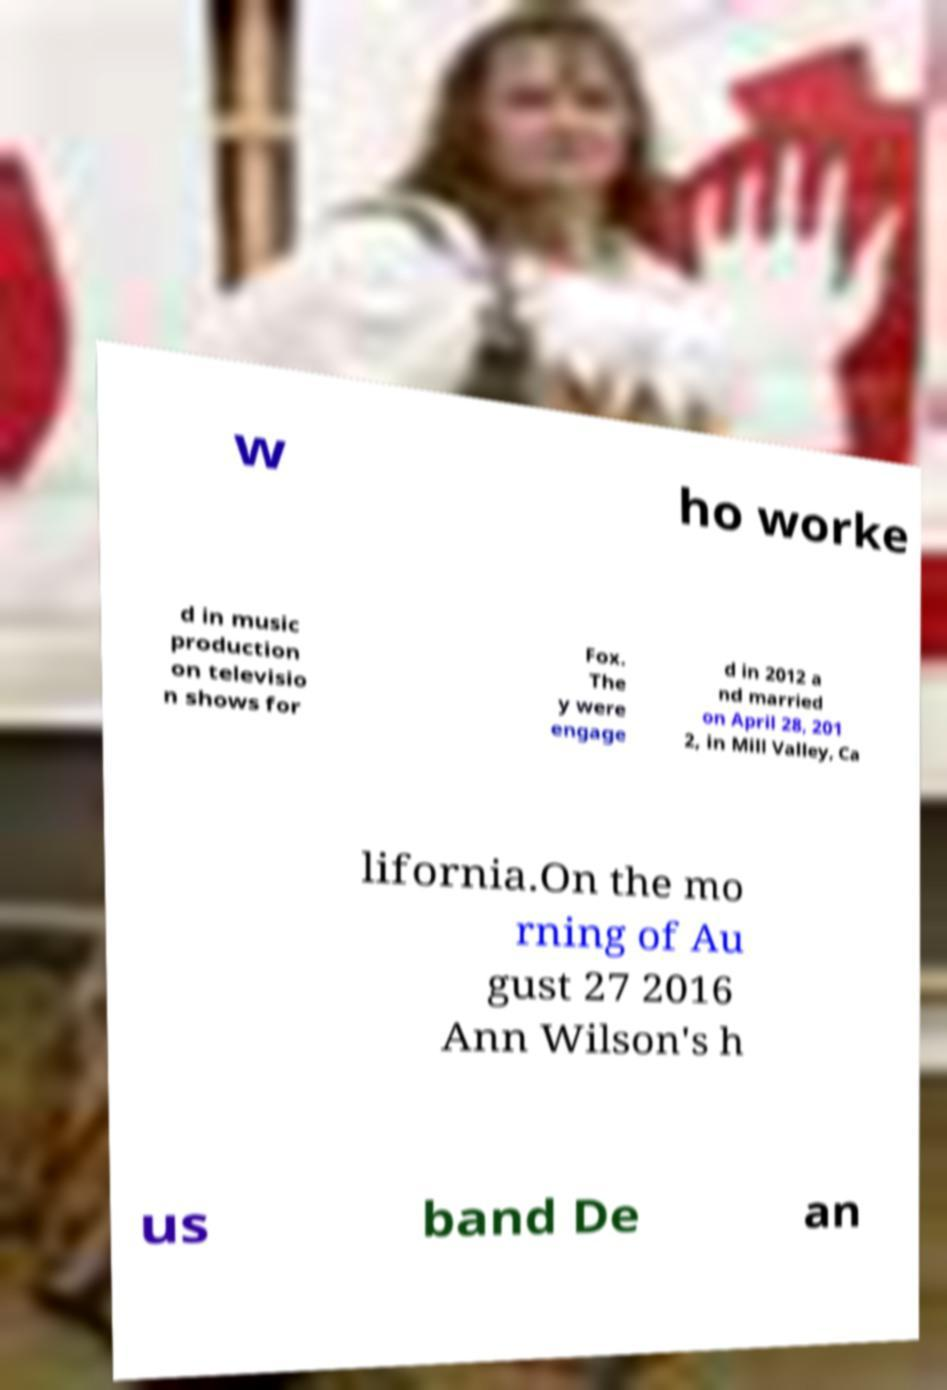For documentation purposes, I need the text within this image transcribed. Could you provide that? w ho worke d in music production on televisio n shows for Fox. The y were engage d in 2012 a nd married on April 28, 201 2, in Mill Valley, Ca lifornia.On the mo rning of Au gust 27 2016 Ann Wilson's h us band De an 